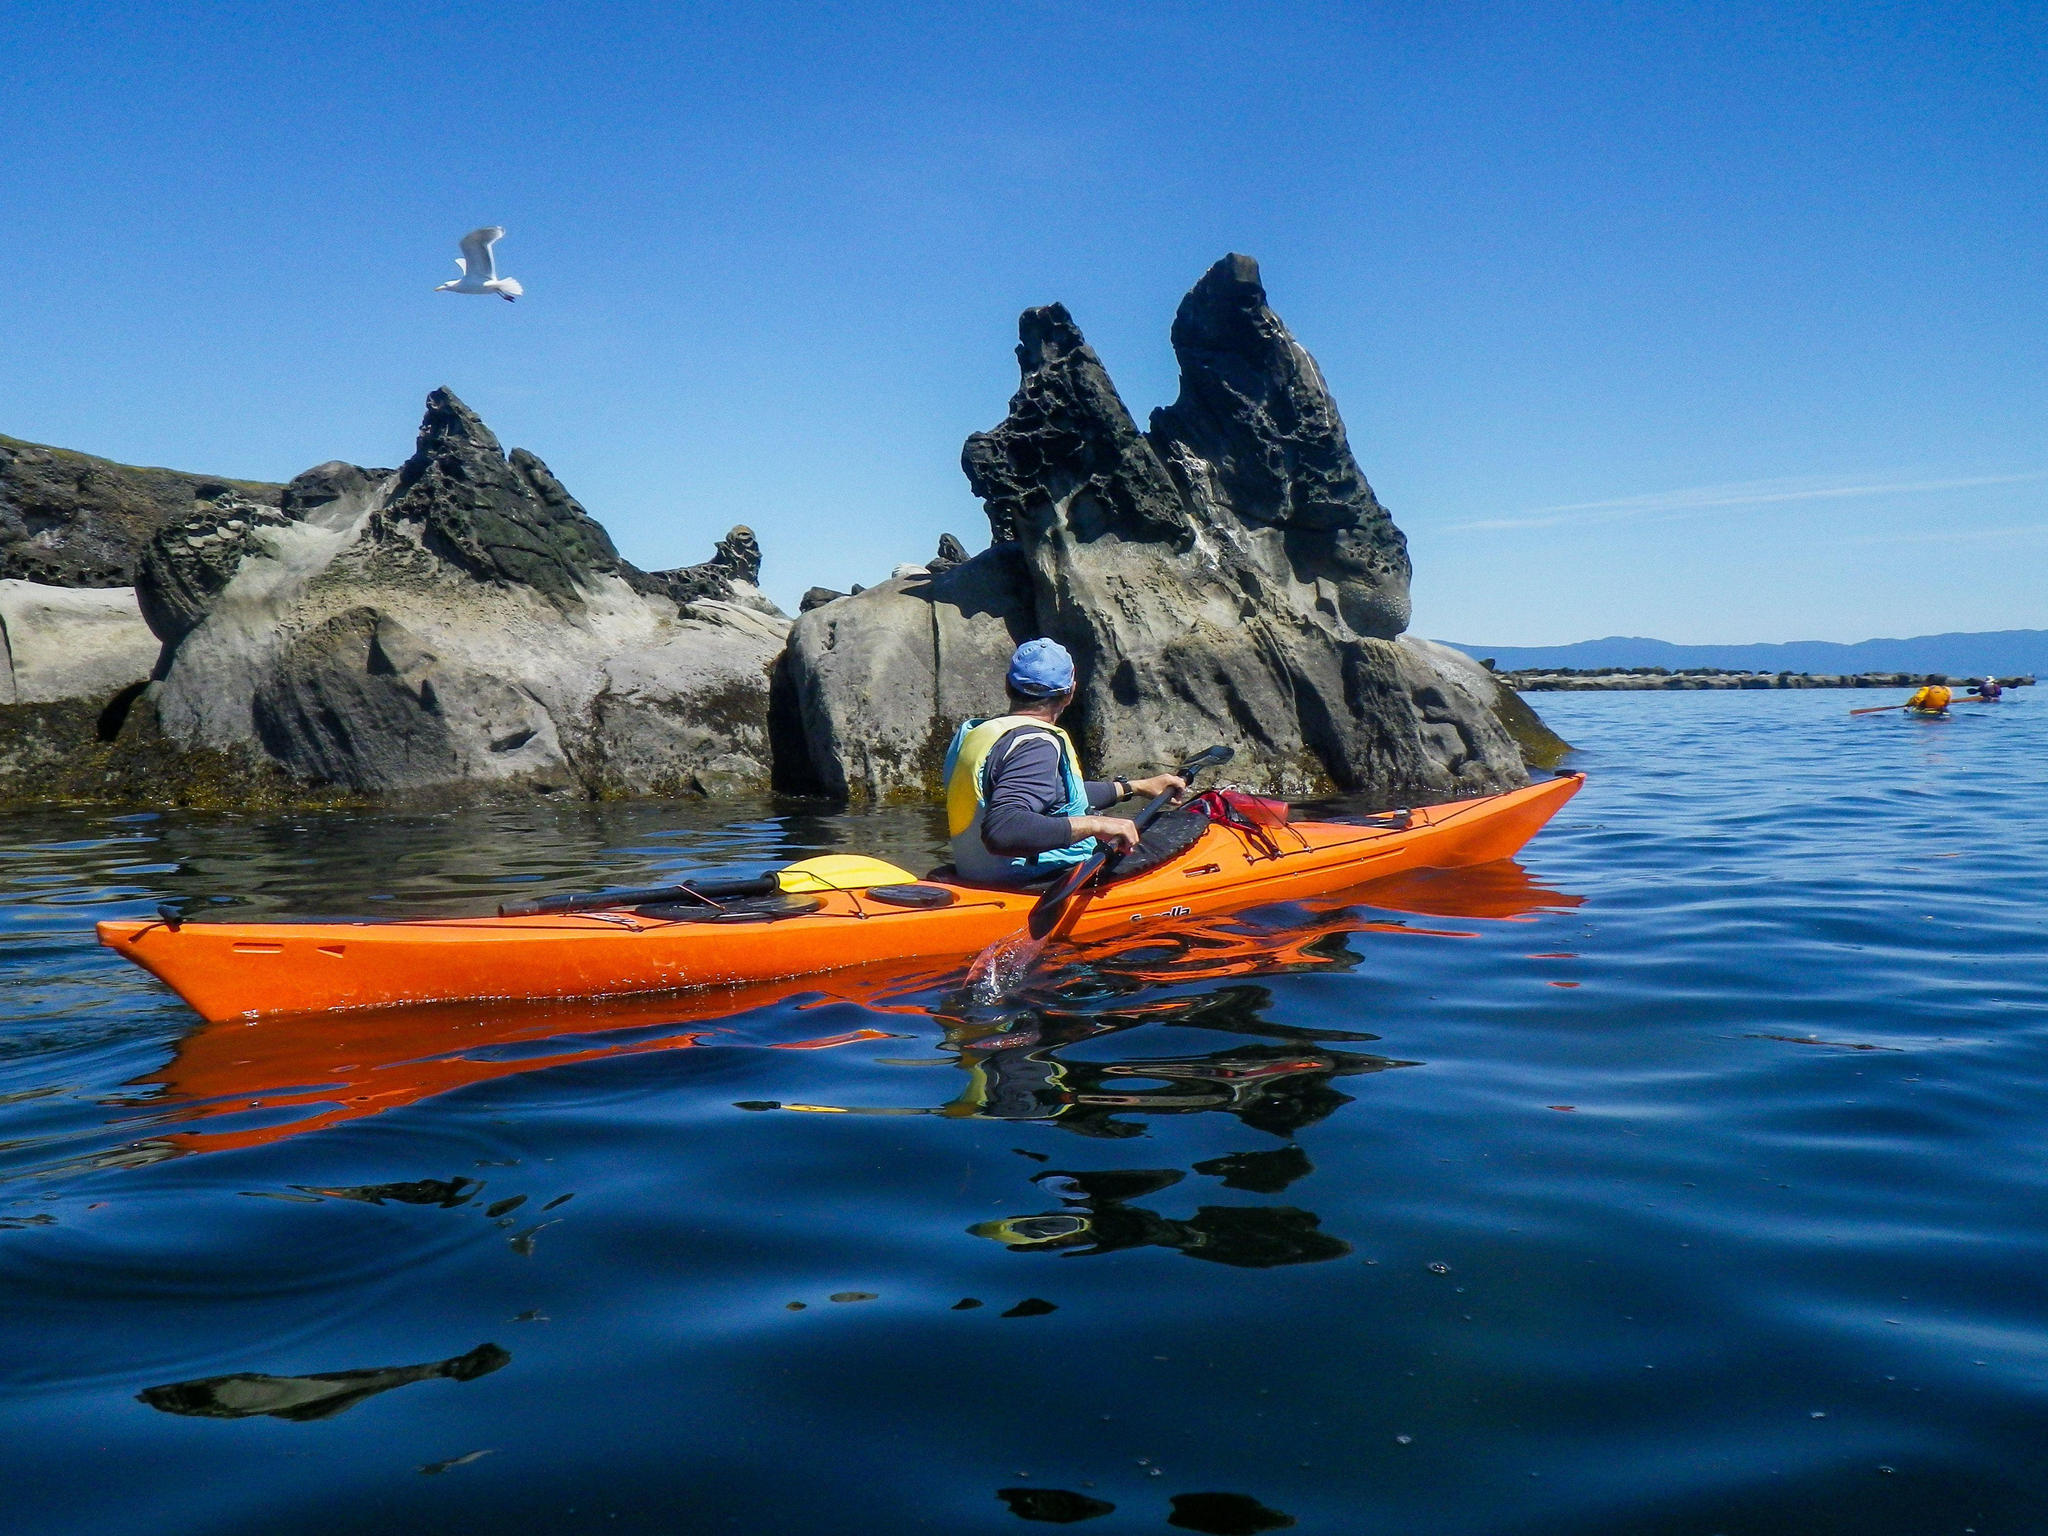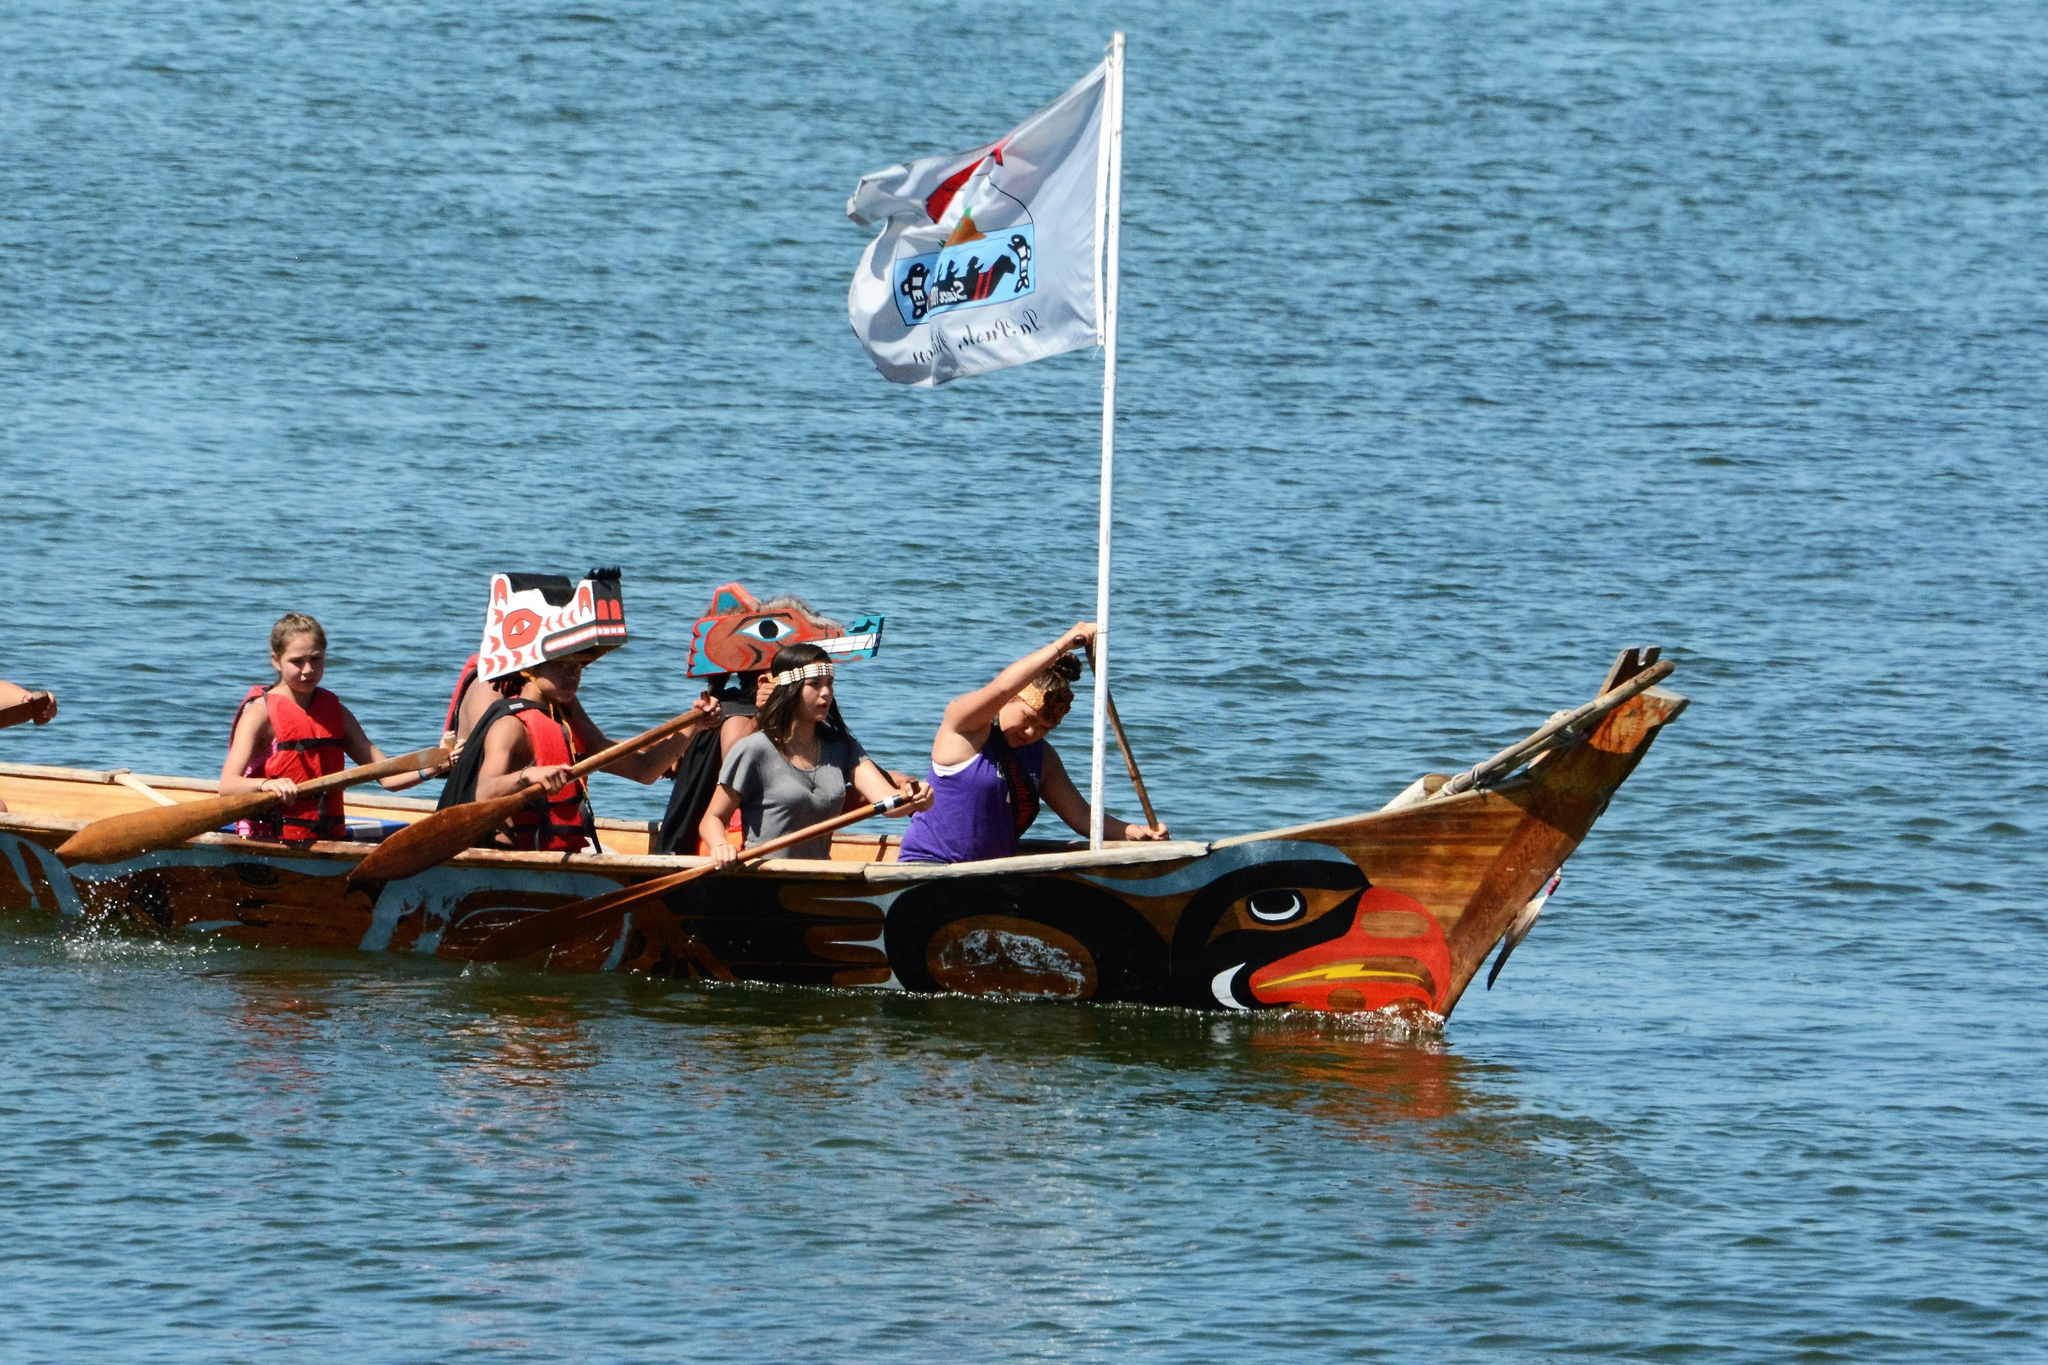The first image is the image on the left, the second image is the image on the right. For the images shown, is this caption "There is a single man paddling a kayak in the left image." true? Answer yes or no. Yes. The first image is the image on the left, the second image is the image on the right. Examine the images to the left and right. Is the description "An image shows a single boat, which has at least four rowers." accurate? Answer yes or no. Yes. 